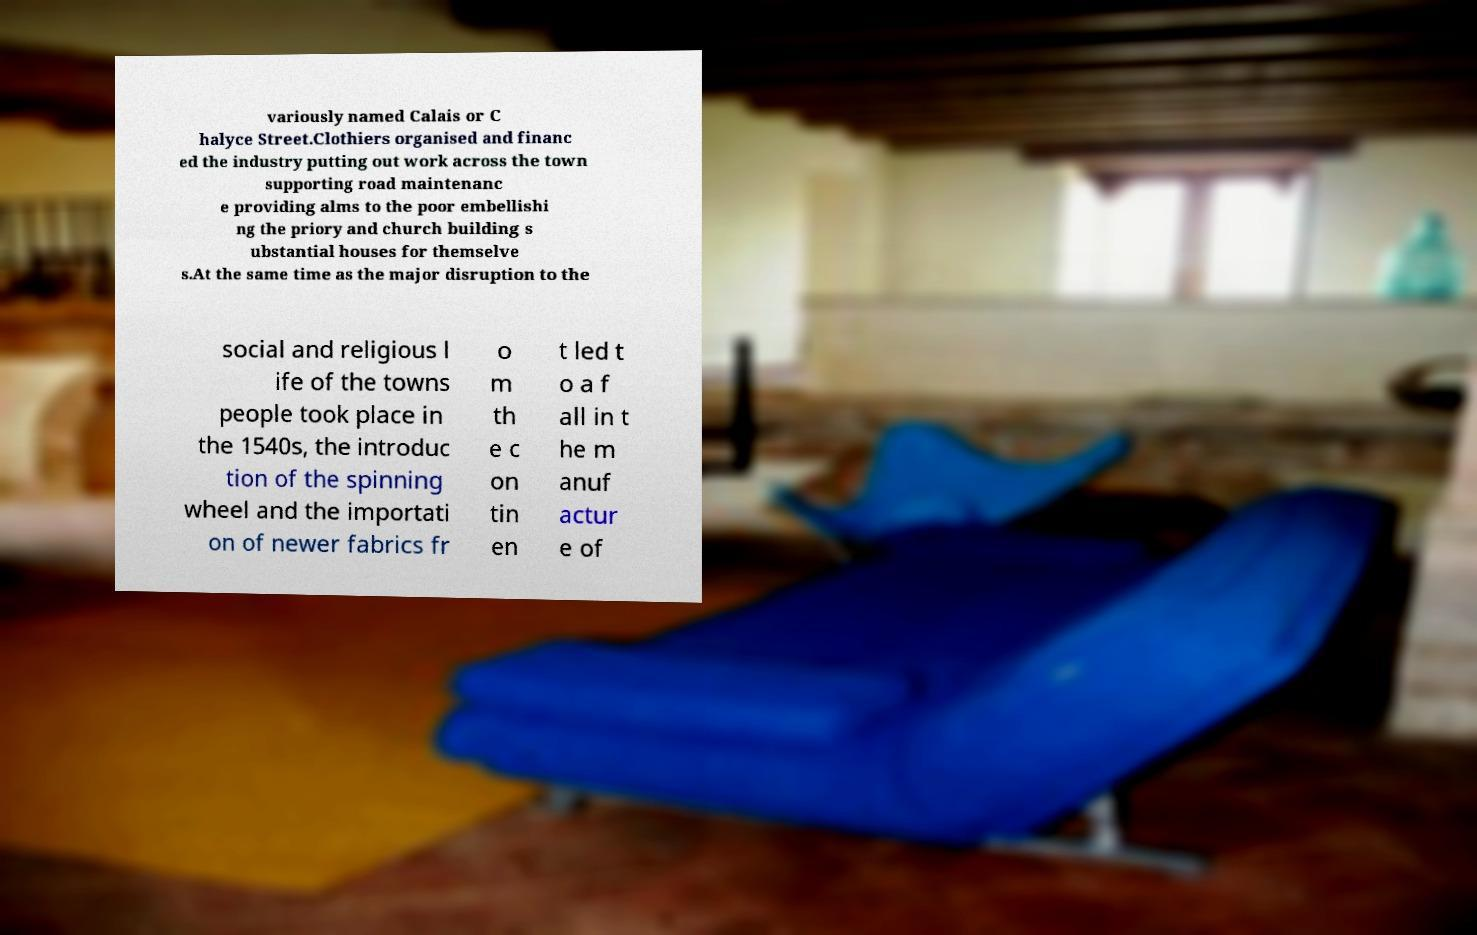I need the written content from this picture converted into text. Can you do that? variously named Calais or C halyce Street.Clothiers organised and financ ed the industry putting out work across the town supporting road maintenanc e providing alms to the poor embellishi ng the priory and church building s ubstantial houses for themselve s.At the same time as the major disruption to the social and religious l ife of the towns people took place in the 1540s, the introduc tion of the spinning wheel and the importati on of newer fabrics fr o m th e c on tin en t led t o a f all in t he m anuf actur e of 